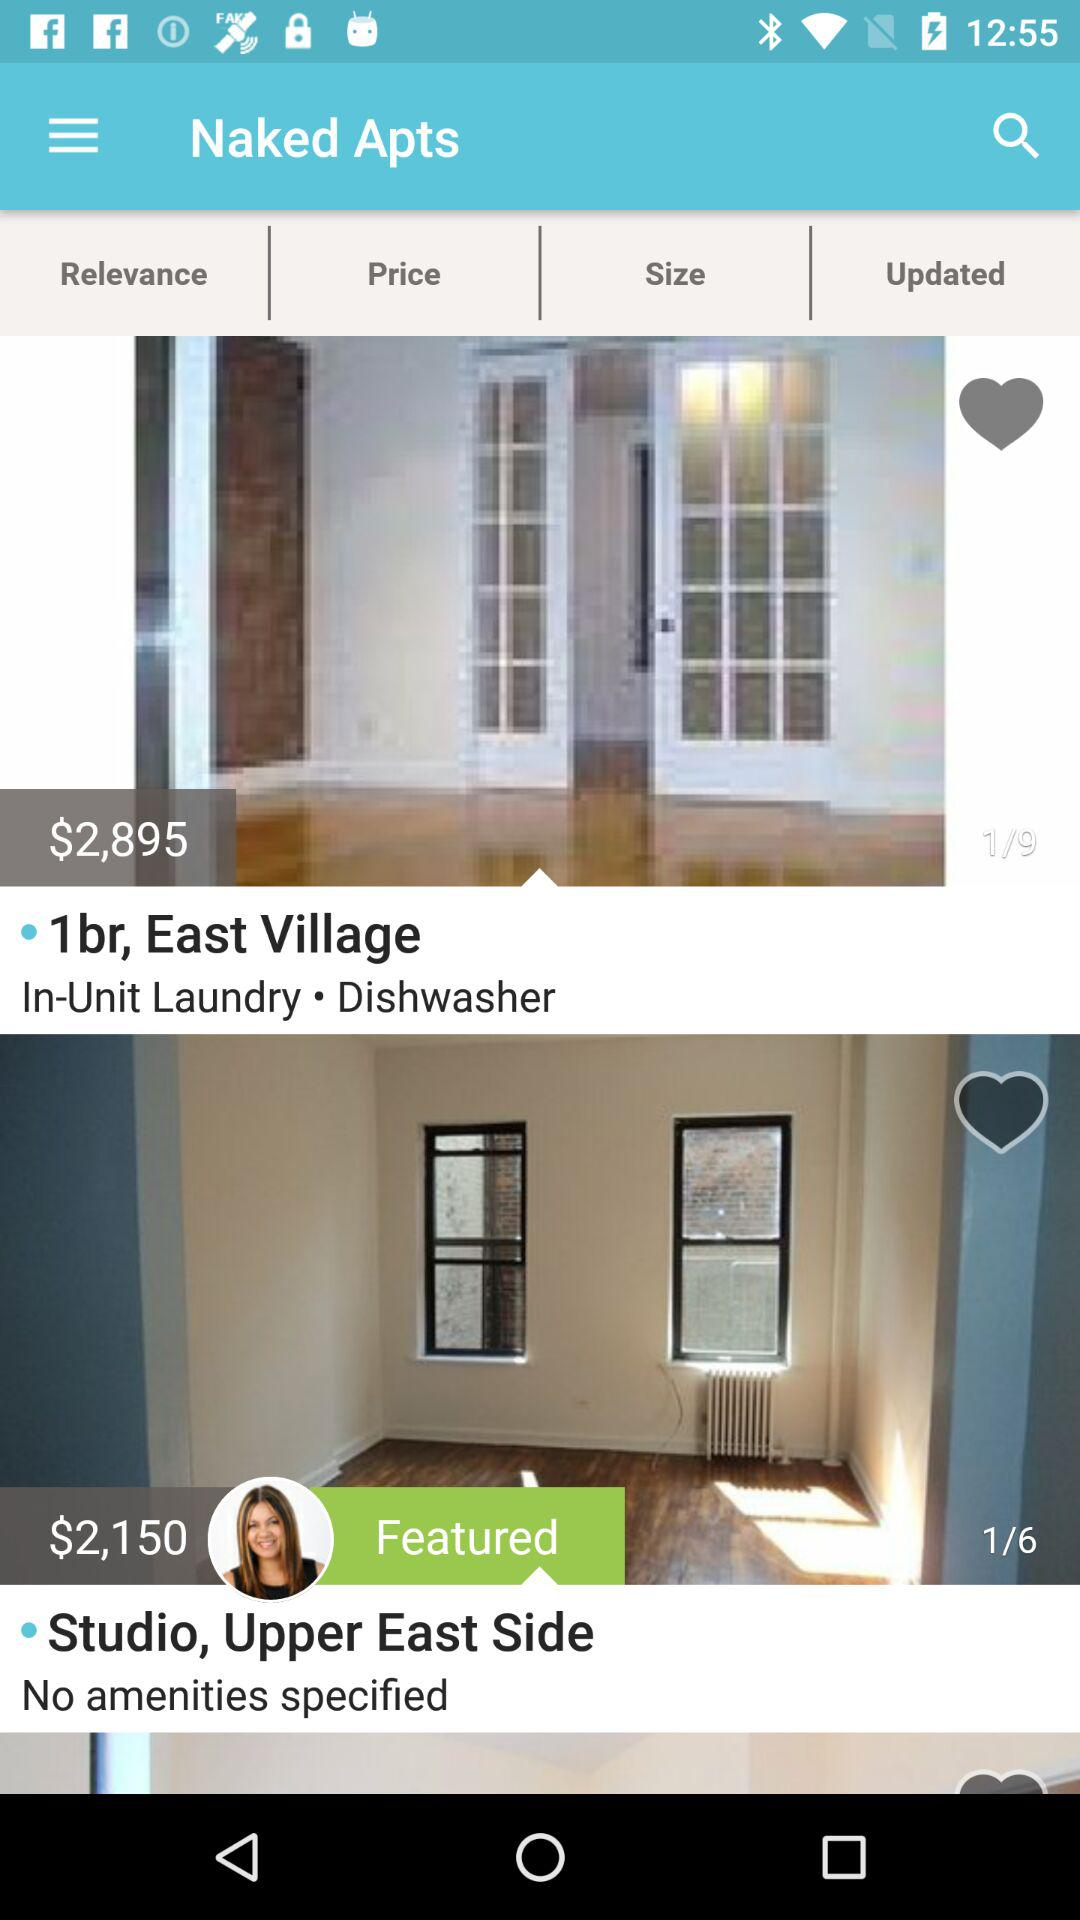What is the application name?
When the provided information is insufficient, respond with <no answer>. <no answer> 